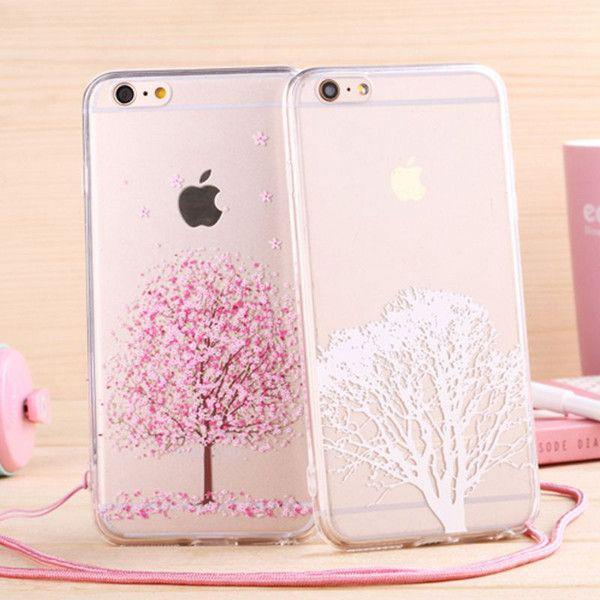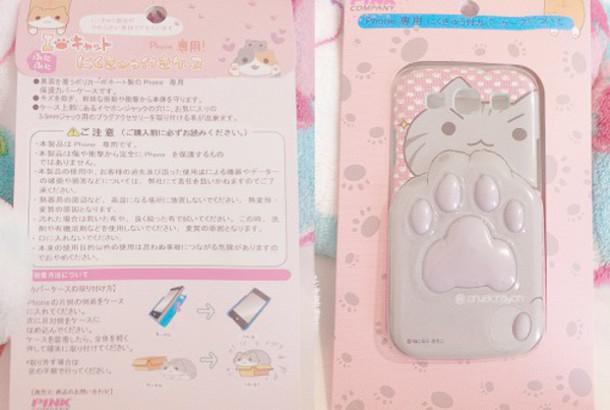The first image is the image on the left, the second image is the image on the right. Evaluate the accuracy of this statement regarding the images: "All of the iPhone cases in the images have a clear back that is decorated with flower blossoms.". Is it true? Answer yes or no. No. The first image is the image on the left, the second image is the image on the right. Considering the images on both sides, is "The right image shows a rectangular device decorated with a cartoon cat face and at least one paw print." valid? Answer yes or no. Yes. 